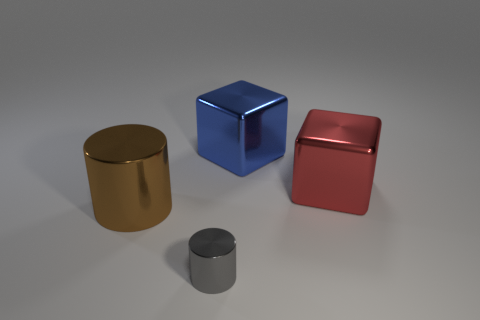Can you describe the lighting in the scene? The scene has soft, diffuse overhead lighting, which creates gentle shadows underneath the objects, indicating that the light source is probably out of view, possibly a studio light setup to evenly illuminate the scene. 